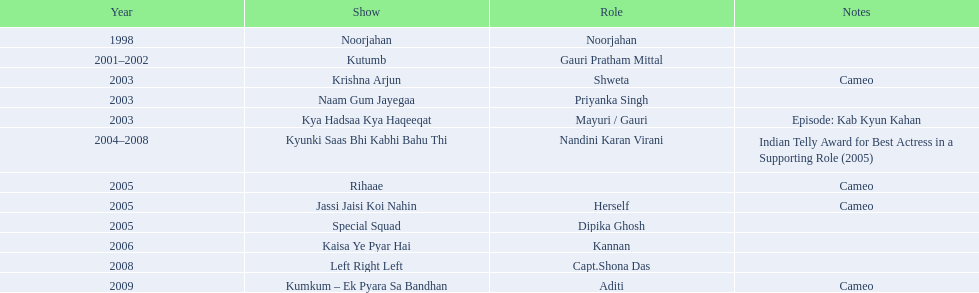In which television series has gauri pradhan tejwani appeared? Noorjahan, Kutumb, Krishna Arjun, Naam Gum Jayegaa, Kya Hadsaa Kya Haqeeqat, Kyunki Saas Bhi Kabhi Bahu Thi, Rihaae, Jassi Jaisi Koi Nahin, Special Squad, Kaisa Ye Pyar Hai, Left Right Left, Kumkum – Ek Pyara Sa Bandhan. Among them, which one continued for over a year? Kutumb, Kyunki Saas Bhi Kabhi Bahu Thi. Which one had the longest duration? Kyunki Saas Bhi Kabhi Bahu Thi. 